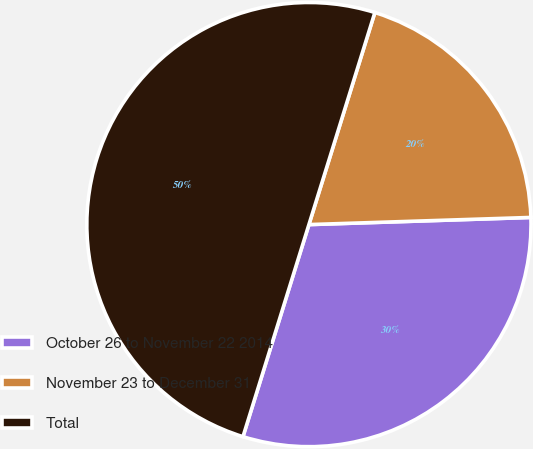<chart> <loc_0><loc_0><loc_500><loc_500><pie_chart><fcel>October 26 to November 22 2014<fcel>November 23 to December 31<fcel>Total<nl><fcel>30.31%<fcel>19.69%<fcel>50.0%<nl></chart> 